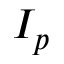<formula> <loc_0><loc_0><loc_500><loc_500>I _ { p }</formula> 